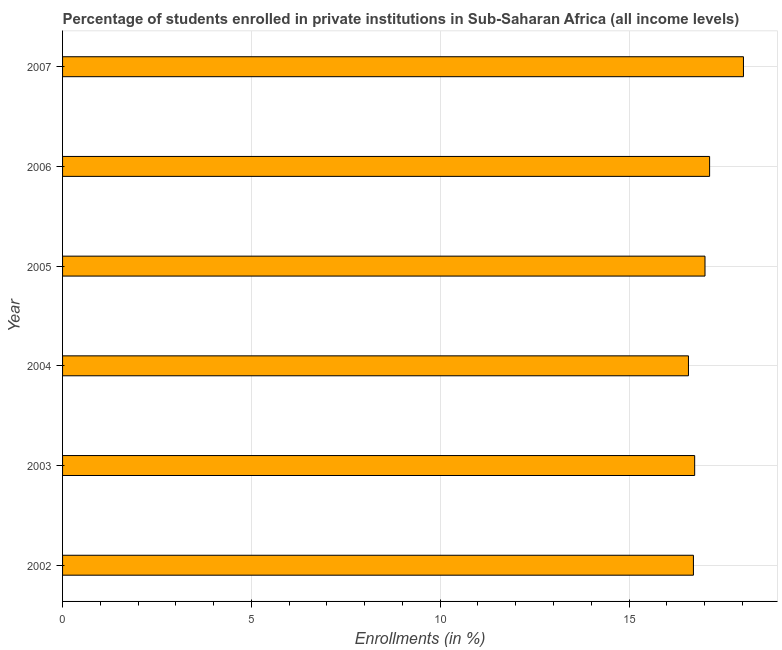Does the graph contain grids?
Ensure brevity in your answer.  Yes. What is the title of the graph?
Make the answer very short. Percentage of students enrolled in private institutions in Sub-Saharan Africa (all income levels). What is the label or title of the X-axis?
Offer a terse response. Enrollments (in %). What is the enrollments in private institutions in 2005?
Your answer should be very brief. 17.01. Across all years, what is the maximum enrollments in private institutions?
Offer a terse response. 18.03. Across all years, what is the minimum enrollments in private institutions?
Ensure brevity in your answer.  16.57. In which year was the enrollments in private institutions minimum?
Make the answer very short. 2004. What is the sum of the enrollments in private institutions?
Give a very brief answer. 102.19. What is the difference between the enrollments in private institutions in 2005 and 2006?
Give a very brief answer. -0.12. What is the average enrollments in private institutions per year?
Offer a very short reply. 17.03. What is the median enrollments in private institutions?
Offer a very short reply. 16.87. In how many years, is the enrollments in private institutions greater than 1 %?
Keep it short and to the point. 6. Do a majority of the years between 2006 and 2005 (inclusive) have enrollments in private institutions greater than 9 %?
Offer a very short reply. No. What is the ratio of the enrollments in private institutions in 2004 to that in 2007?
Your response must be concise. 0.92. Is the enrollments in private institutions in 2004 less than that in 2005?
Give a very brief answer. Yes. What is the difference between the highest and the second highest enrollments in private institutions?
Make the answer very short. 0.9. Is the sum of the enrollments in private institutions in 2006 and 2007 greater than the maximum enrollments in private institutions across all years?
Give a very brief answer. Yes. What is the difference between the highest and the lowest enrollments in private institutions?
Your answer should be very brief. 1.46. How many bars are there?
Ensure brevity in your answer.  6. What is the difference between two consecutive major ticks on the X-axis?
Provide a short and direct response. 5. What is the Enrollments (in %) in 2002?
Make the answer very short. 16.71. What is the Enrollments (in %) in 2003?
Your answer should be very brief. 16.74. What is the Enrollments (in %) in 2004?
Provide a short and direct response. 16.57. What is the Enrollments (in %) of 2005?
Give a very brief answer. 17.01. What is the Enrollments (in %) in 2006?
Offer a terse response. 17.13. What is the Enrollments (in %) in 2007?
Your answer should be compact. 18.03. What is the difference between the Enrollments (in %) in 2002 and 2003?
Offer a terse response. -0.03. What is the difference between the Enrollments (in %) in 2002 and 2004?
Provide a succinct answer. 0.13. What is the difference between the Enrollments (in %) in 2002 and 2005?
Provide a succinct answer. -0.31. What is the difference between the Enrollments (in %) in 2002 and 2006?
Provide a succinct answer. -0.43. What is the difference between the Enrollments (in %) in 2002 and 2007?
Keep it short and to the point. -1.32. What is the difference between the Enrollments (in %) in 2003 and 2004?
Your answer should be compact. 0.16. What is the difference between the Enrollments (in %) in 2003 and 2005?
Your response must be concise. -0.27. What is the difference between the Enrollments (in %) in 2003 and 2006?
Provide a succinct answer. -0.4. What is the difference between the Enrollments (in %) in 2003 and 2007?
Give a very brief answer. -1.29. What is the difference between the Enrollments (in %) in 2004 and 2005?
Provide a succinct answer. -0.44. What is the difference between the Enrollments (in %) in 2004 and 2006?
Offer a terse response. -0.56. What is the difference between the Enrollments (in %) in 2004 and 2007?
Provide a succinct answer. -1.46. What is the difference between the Enrollments (in %) in 2005 and 2006?
Make the answer very short. -0.12. What is the difference between the Enrollments (in %) in 2005 and 2007?
Make the answer very short. -1.02. What is the difference between the Enrollments (in %) in 2006 and 2007?
Your response must be concise. -0.9. What is the ratio of the Enrollments (in %) in 2002 to that in 2004?
Your answer should be compact. 1.01. What is the ratio of the Enrollments (in %) in 2002 to that in 2005?
Make the answer very short. 0.98. What is the ratio of the Enrollments (in %) in 2002 to that in 2007?
Your answer should be compact. 0.93. What is the ratio of the Enrollments (in %) in 2003 to that in 2007?
Keep it short and to the point. 0.93. What is the ratio of the Enrollments (in %) in 2004 to that in 2005?
Make the answer very short. 0.97. What is the ratio of the Enrollments (in %) in 2004 to that in 2007?
Your response must be concise. 0.92. What is the ratio of the Enrollments (in %) in 2005 to that in 2006?
Your answer should be compact. 0.99. What is the ratio of the Enrollments (in %) in 2005 to that in 2007?
Your answer should be very brief. 0.94. What is the ratio of the Enrollments (in %) in 2006 to that in 2007?
Your response must be concise. 0.95. 